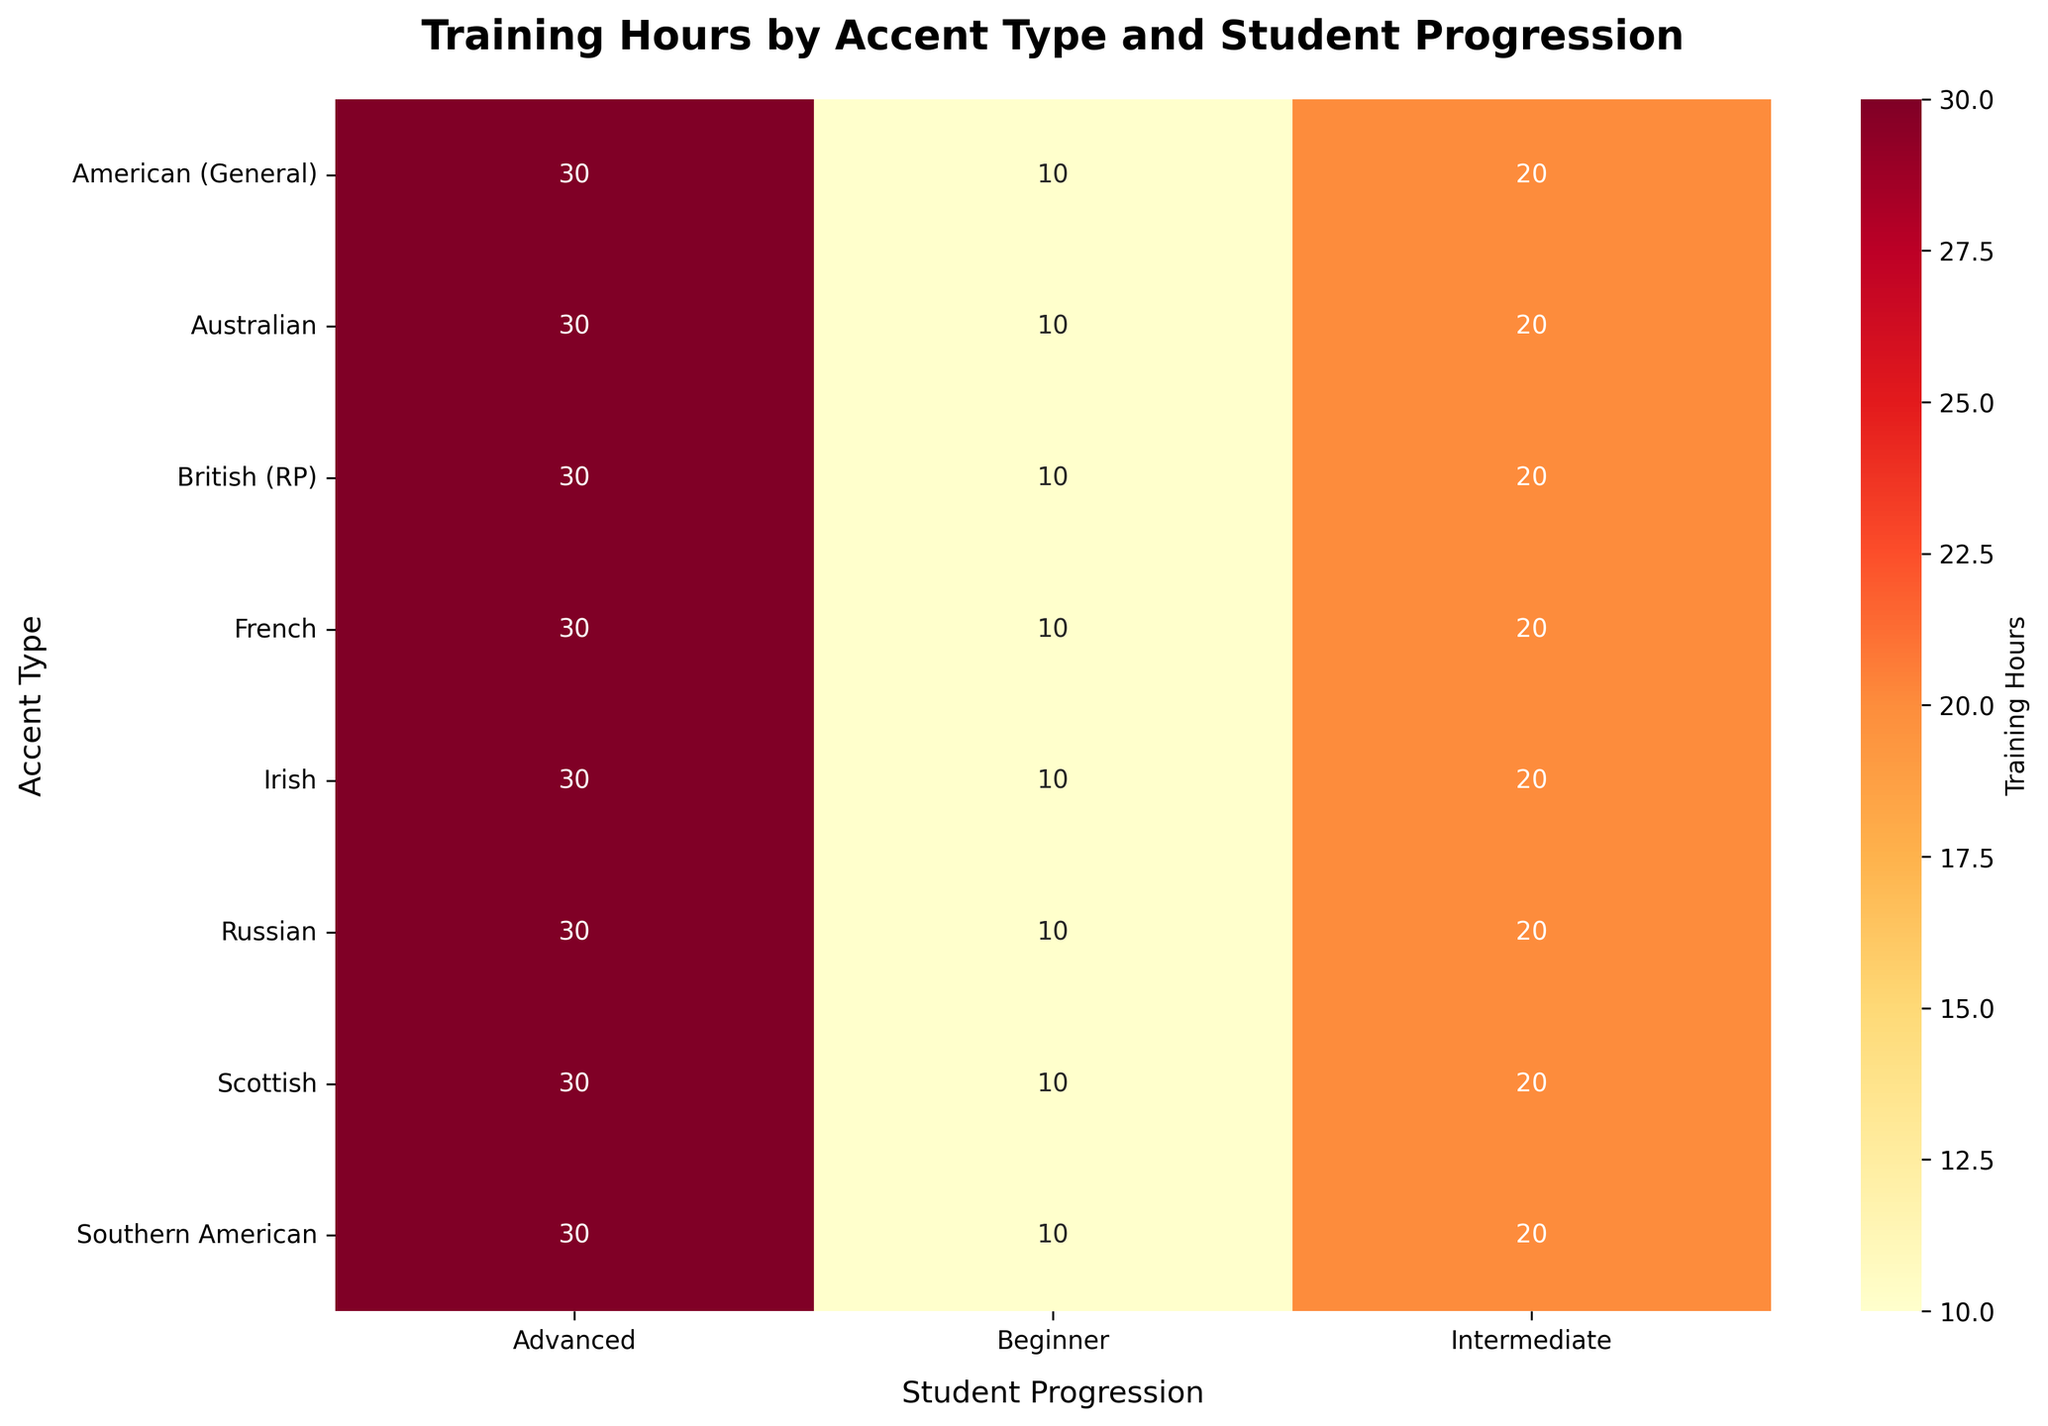Which accent type has the highest training hours for advanced students? From the heatmap, locate the row corresponding to advanced students. Identify the accent type with the highest value in that row.
Answer: British (RP) What are the training hours required for intermediate progression in the Australian accent? Check the row for the Australian accent and find the column for intermediate progression. There, you will see the training hours.
Answer: 20 Compare the training hours for beginner-level students between the Irish and French accents. Which one requires more hours? Look at the beginner column for both the Irish and French accents. Compare their values.
Answer: They are the same What is the total training hours for the Russian accent across all progression levels? Sum the hours for the Russian accent in the beginner, intermediate, and advanced columns: 10 (Beginner) + 20 (Intermediate) + 30 (Advanced).
Answer: 60 How many accent types have equal training hours for all three progression levels? Scan each row in the heatmap. Count the number of accent types where the values in the beginner, intermediate, and advanced columns are equal.
Answer: None Which progression level generally requires the least training hours across all accent types? Compare the overall patterns in the heatmap. Identify which of the beginner, intermediate, or advanced columns has the lowest values.
Answer: Beginner How much more training is required for advanced progression compared to intermediate progression in the Southern American accent? Subtract the training hours for intermediate progression from the advanced progression in the Southern American row: 30 (Advanced) - 20 (Intermediate).
Answer: 10 For the British (RP) and American (General) accents, compare the training hours required for intermediate progression. Are they the same or different? Look at the intermediate column for both British (RP) and American (General) rows and compare their values.
Answer: They are the same What is the average training hours for intermediate progression across all accent types? Add the training hours for intermediate progression for all accents and divide by the number of accents (total 9): (20+20+20+20+20+20+20+20+20)/9.
Answer: 20 